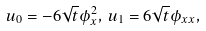<formula> <loc_0><loc_0><loc_500><loc_500>u _ { 0 } = - 6 \sqrt { t } \phi _ { x } ^ { 2 } , \, u _ { 1 } = 6 \sqrt { t } \phi _ { x x } ,</formula> 